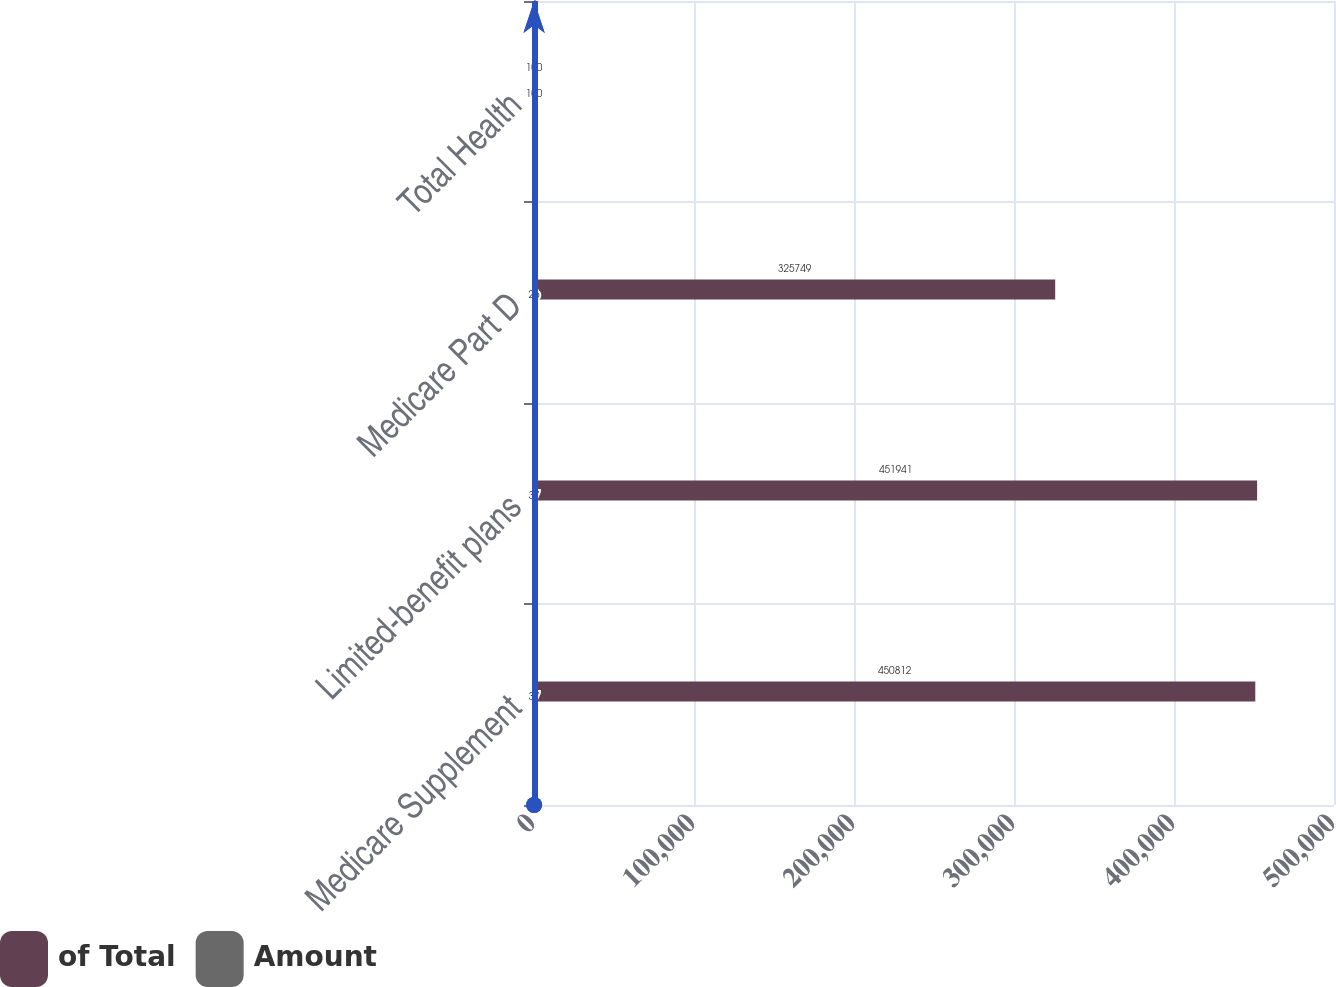Convert chart to OTSL. <chart><loc_0><loc_0><loc_500><loc_500><stacked_bar_chart><ecel><fcel>Medicare Supplement<fcel>Limited-benefit plans<fcel>Medicare Part D<fcel>Total Health<nl><fcel>of Total<fcel>450812<fcel>451941<fcel>325749<fcel>100<nl><fcel>Amount<fcel>37<fcel>37<fcel>26<fcel>100<nl></chart> 